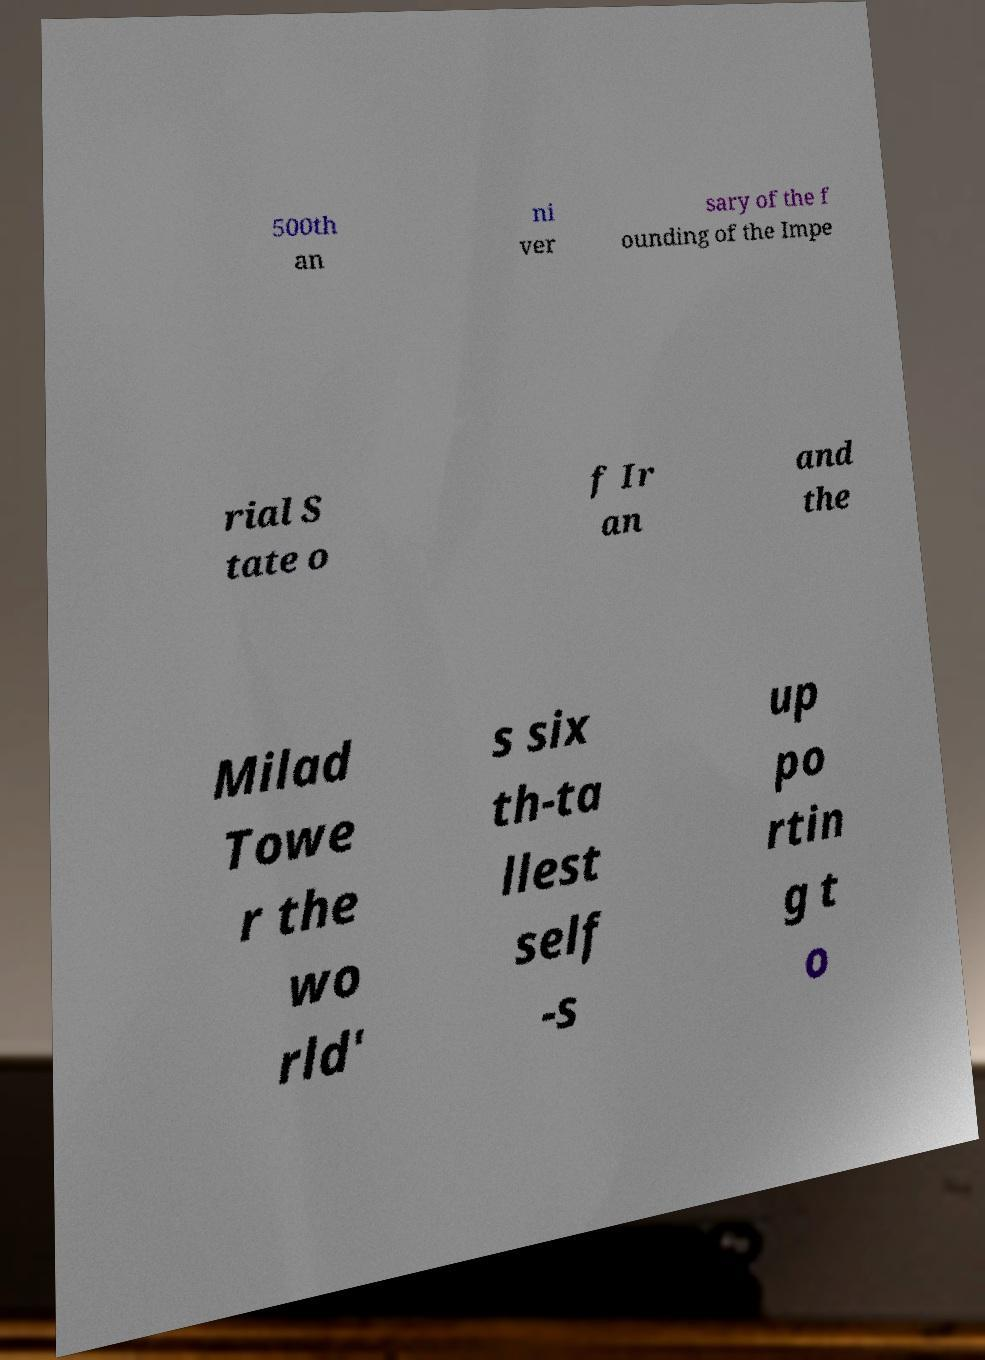Can you read and provide the text displayed in the image?This photo seems to have some interesting text. Can you extract and type it out for me? 500th an ni ver sary of the f ounding of the Impe rial S tate o f Ir an and the Milad Towe r the wo rld' s six th-ta llest self -s up po rtin g t o 